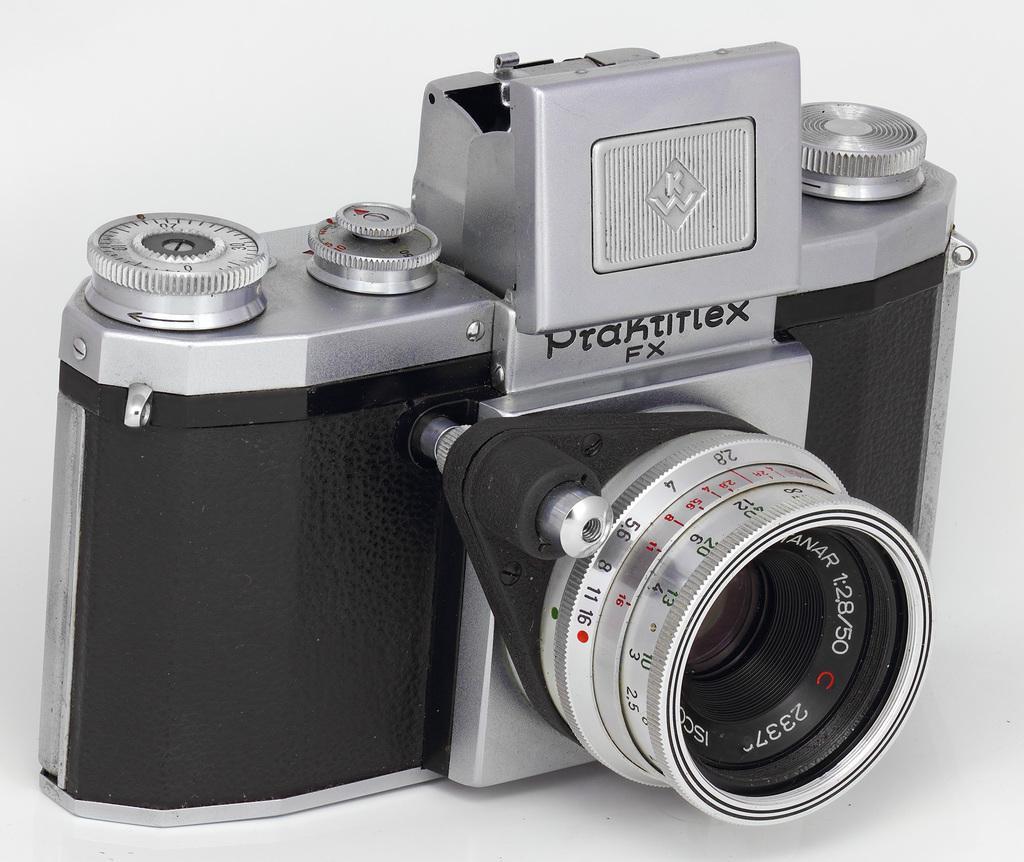Please provide a concise description of this image. In this picture we can see a camera is present on the surface. On the camera we can see the text. 